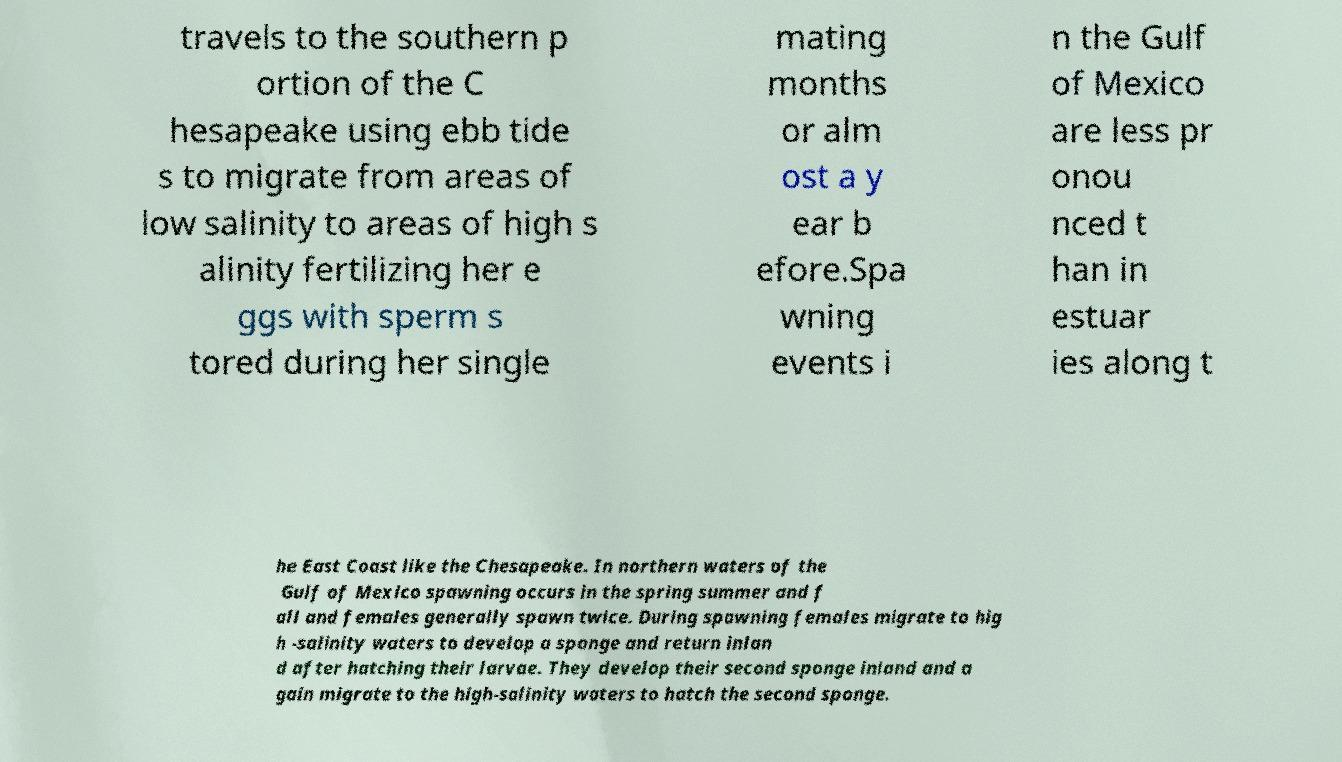Could you assist in decoding the text presented in this image and type it out clearly? travels to the southern p ortion of the C hesapeake using ebb tide s to migrate from areas of low salinity to areas of high s alinity fertilizing her e ggs with sperm s tored during her single mating months or alm ost a y ear b efore.Spa wning events i n the Gulf of Mexico are less pr onou nced t han in estuar ies along t he East Coast like the Chesapeake. In northern waters of the Gulf of Mexico spawning occurs in the spring summer and f all and females generally spawn twice. During spawning females migrate to hig h -salinity waters to develop a sponge and return inlan d after hatching their larvae. They develop their second sponge inland and a gain migrate to the high-salinity waters to hatch the second sponge. 